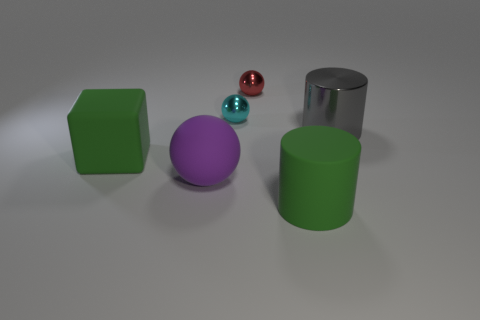There is another tiny object that is the same shape as the small red object; what is it made of?
Make the answer very short. Metal. There is a cylinder that is in front of the gray cylinder; how big is it?
Make the answer very short. Large. Is the size of the matte cylinder the same as the purple object?
Your response must be concise. Yes. How big is the green rubber object in front of the large green matte object to the left of the purple matte sphere?
Your answer should be very brief. Large. There is a thing that is both on the right side of the red sphere and left of the metallic cylinder; what is its size?
Ensure brevity in your answer.  Large. What number of other metallic cylinders are the same size as the gray cylinder?
Your answer should be compact. 0. What number of metallic things are small red balls or cylinders?
Offer a very short reply. 2. There is a cylinder that is the same color as the big cube; what size is it?
Your answer should be compact. Large. The large thing on the right side of the large cylinder that is on the left side of the gray metallic cylinder is made of what material?
Provide a short and direct response. Metal. What number of objects are either big purple things or metallic things to the right of the tiny cyan metal thing?
Your answer should be very brief. 3. 